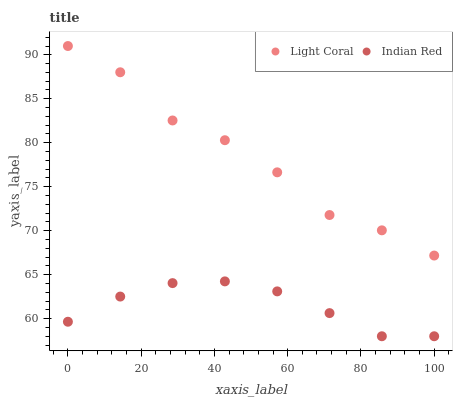Does Indian Red have the minimum area under the curve?
Answer yes or no. Yes. Does Light Coral have the maximum area under the curve?
Answer yes or no. Yes. Does Indian Red have the maximum area under the curve?
Answer yes or no. No. Is Indian Red the smoothest?
Answer yes or no. Yes. Is Light Coral the roughest?
Answer yes or no. Yes. Is Indian Red the roughest?
Answer yes or no. No. Does Indian Red have the lowest value?
Answer yes or no. Yes. Does Light Coral have the highest value?
Answer yes or no. Yes. Does Indian Red have the highest value?
Answer yes or no. No. Is Indian Red less than Light Coral?
Answer yes or no. Yes. Is Light Coral greater than Indian Red?
Answer yes or no. Yes. Does Indian Red intersect Light Coral?
Answer yes or no. No. 